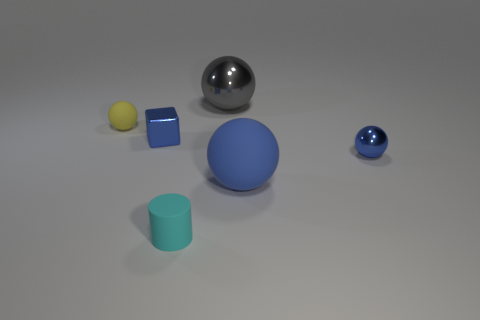What number of other things are the same color as the small shiny cube?
Your answer should be compact. 2. Are there fewer large gray objects that are in front of the tiny cube than tiny cylinders?
Keep it short and to the point. Yes. Are there any purple metal balls that have the same size as the cyan rubber cylinder?
Your answer should be compact. No. Is the color of the block the same as the small matte thing to the right of the block?
Provide a succinct answer. No. There is a cyan cylinder that is to the right of the yellow sphere; how many cyan objects are left of it?
Your answer should be compact. 0. The shiny object on the right side of the large shiny thing behind the cyan matte cylinder is what color?
Your answer should be compact. Blue. What material is the ball that is both behind the blue block and on the right side of the tiny cylinder?
Ensure brevity in your answer.  Metal. Is there another rubber object that has the same shape as the large blue object?
Your response must be concise. Yes. Do the large thing behind the yellow rubber thing and the small yellow thing have the same shape?
Make the answer very short. Yes. How many rubber objects are both on the right side of the tiny metallic block and on the left side of the blue matte sphere?
Provide a succinct answer. 1. 